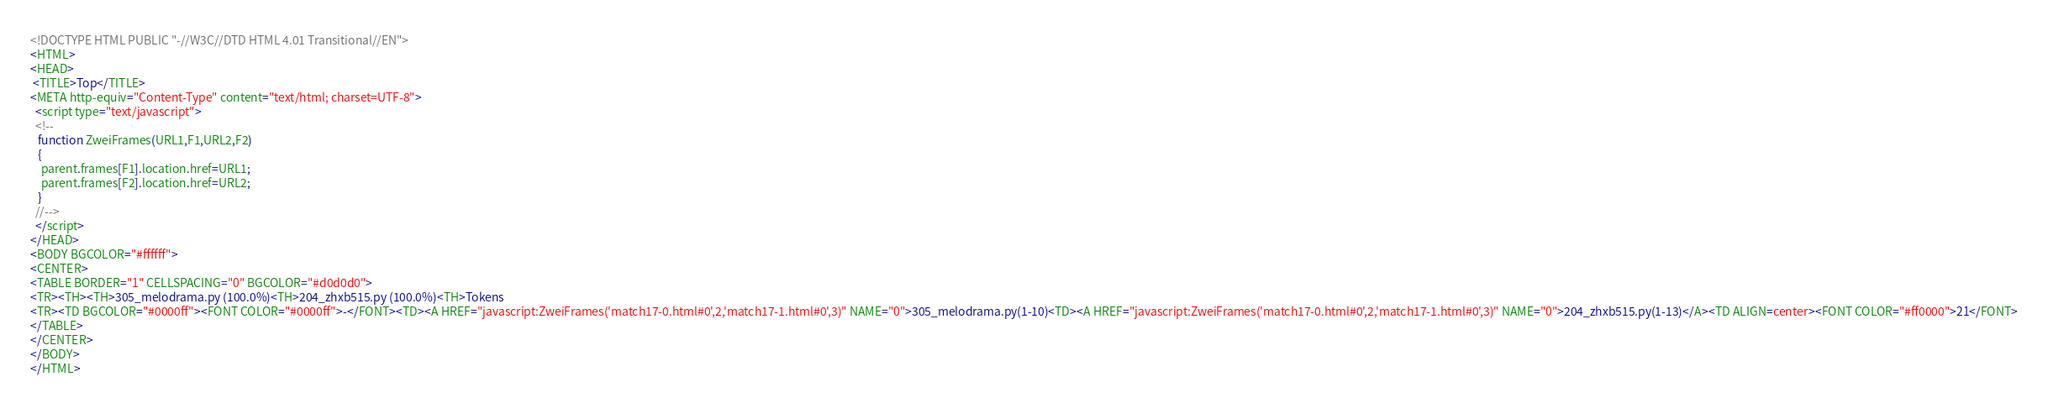<code> <loc_0><loc_0><loc_500><loc_500><_HTML_><!DOCTYPE HTML PUBLIC "-//W3C//DTD HTML 4.01 Transitional//EN">
<HTML>
<HEAD>
 <TITLE>Top</TITLE>
<META http-equiv="Content-Type" content="text/html; charset=UTF-8">
  <script type="text/javascript">
  <!--
   function ZweiFrames(URL1,F1,URL2,F2)
   {
    parent.frames[F1].location.href=URL1;
    parent.frames[F2].location.href=URL2;
   }
  //-->
  </script>
</HEAD>
<BODY BGCOLOR="#ffffff">
<CENTER>
<TABLE BORDER="1" CELLSPACING="0" BGCOLOR="#d0d0d0">
<TR><TH><TH>305_melodrama.py (100.0%)<TH>204_zhxb515.py (100.0%)<TH>Tokens
<TR><TD BGCOLOR="#0000ff"><FONT COLOR="#0000ff">-</FONT><TD><A HREF="javascript:ZweiFrames('match17-0.html#0',2,'match17-1.html#0',3)" NAME="0">305_melodrama.py(1-10)<TD><A HREF="javascript:ZweiFrames('match17-0.html#0',2,'match17-1.html#0',3)" NAME="0">204_zhxb515.py(1-13)</A><TD ALIGN=center><FONT COLOR="#ff0000">21</FONT>
</TABLE>
</CENTER>
</BODY>
</HTML>

</code> 